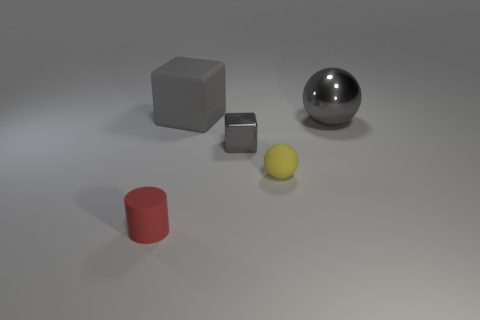Subtract 1 spheres. How many spheres are left? 1 Subtract all balls. How many objects are left? 3 Add 2 matte cubes. How many objects exist? 7 Subtract all purple cubes. How many yellow spheres are left? 1 Add 5 rubber spheres. How many rubber spheres are left? 6 Add 5 gray shiny spheres. How many gray shiny spheres exist? 6 Subtract 1 red cylinders. How many objects are left? 4 Subtract all yellow cubes. Subtract all green cylinders. How many cubes are left? 2 Subtract all tiny brown matte objects. Subtract all big gray metallic spheres. How many objects are left? 4 